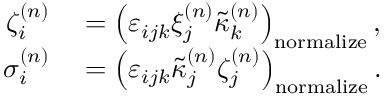<formula> <loc_0><loc_0><loc_500><loc_500>\begin{array} { r l } { \zeta _ { i } ^ { ( n ) } } & = \left ( \varepsilon _ { i j k } \xi _ { j } ^ { ( n ) } \tilde { \kappa } _ { k } ^ { ( n ) } \right ) _ { n o r m a l i z e } , } \\ { \sigma _ { i } ^ { ( n ) } } & = \left ( \varepsilon _ { i j k } \tilde { \kappa } _ { j } ^ { ( n ) } \zeta _ { j } ^ { ( n ) } \right ) _ { n o r m a l i z e } . } \end{array}</formula> 